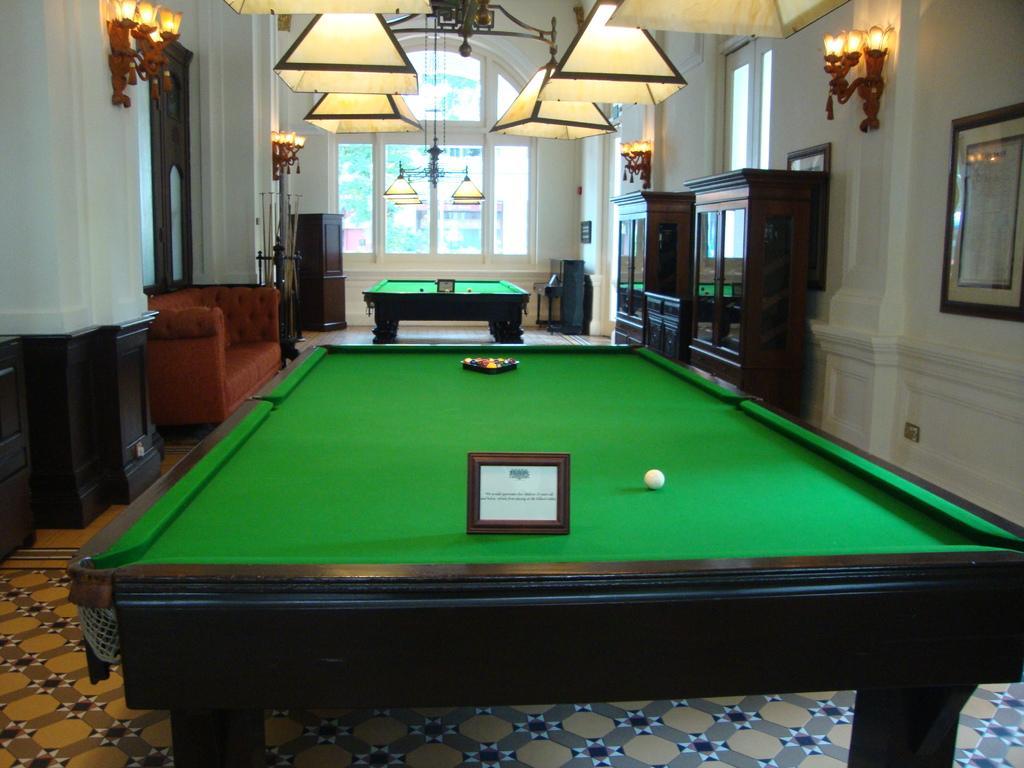Can you describe this image briefly? In this image I can see two snooker tables and a sofa. Here I can see number of lights. 